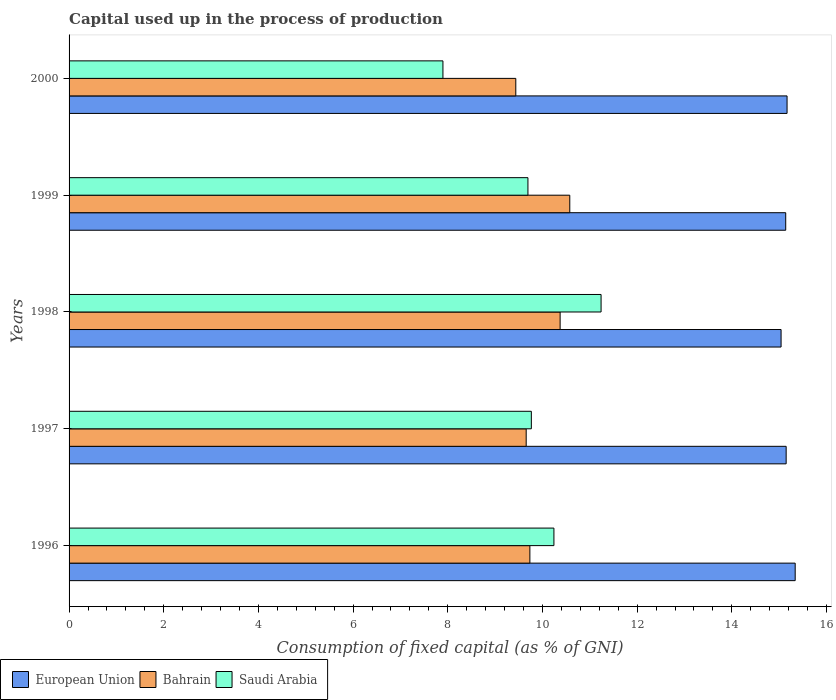How many groups of bars are there?
Offer a terse response. 5. Are the number of bars on each tick of the Y-axis equal?
Your answer should be very brief. Yes. What is the label of the 3rd group of bars from the top?
Offer a terse response. 1998. What is the capital used up in the process of production in Saudi Arabia in 1996?
Your response must be concise. 10.24. Across all years, what is the maximum capital used up in the process of production in Bahrain?
Your answer should be compact. 10.58. Across all years, what is the minimum capital used up in the process of production in European Union?
Your response must be concise. 15.04. In which year was the capital used up in the process of production in European Union maximum?
Provide a succinct answer. 1996. In which year was the capital used up in the process of production in Bahrain minimum?
Give a very brief answer. 2000. What is the total capital used up in the process of production in European Union in the graph?
Make the answer very short. 75.83. What is the difference between the capital used up in the process of production in European Union in 1999 and that in 2000?
Give a very brief answer. -0.03. What is the difference between the capital used up in the process of production in European Union in 2000 and the capital used up in the process of production in Saudi Arabia in 1998?
Your answer should be compact. 3.93. What is the average capital used up in the process of production in Saudi Arabia per year?
Give a very brief answer. 9.77. In the year 1999, what is the difference between the capital used up in the process of production in European Union and capital used up in the process of production in Saudi Arabia?
Offer a very short reply. 5.45. What is the ratio of the capital used up in the process of production in Saudi Arabia in 1997 to that in 2000?
Provide a succinct answer. 1.24. Is the capital used up in the process of production in European Union in 1999 less than that in 2000?
Ensure brevity in your answer.  Yes. What is the difference between the highest and the second highest capital used up in the process of production in Bahrain?
Ensure brevity in your answer.  0.2. What is the difference between the highest and the lowest capital used up in the process of production in Saudi Arabia?
Your response must be concise. 3.34. In how many years, is the capital used up in the process of production in Bahrain greater than the average capital used up in the process of production in Bahrain taken over all years?
Offer a very short reply. 2. Is the sum of the capital used up in the process of production in European Union in 1996 and 1998 greater than the maximum capital used up in the process of production in Saudi Arabia across all years?
Offer a very short reply. Yes. What does the 1st bar from the top in 1998 represents?
Offer a terse response. Saudi Arabia. What does the 3rd bar from the bottom in 2000 represents?
Make the answer very short. Saudi Arabia. Is it the case that in every year, the sum of the capital used up in the process of production in Saudi Arabia and capital used up in the process of production in European Union is greater than the capital used up in the process of production in Bahrain?
Offer a very short reply. Yes. How many bars are there?
Your response must be concise. 15. Are all the bars in the graph horizontal?
Offer a terse response. Yes. How many years are there in the graph?
Offer a very short reply. 5. How are the legend labels stacked?
Your answer should be compact. Horizontal. What is the title of the graph?
Provide a succinct answer. Capital used up in the process of production. What is the label or title of the X-axis?
Keep it short and to the point. Consumption of fixed capital (as % of GNI). What is the Consumption of fixed capital (as % of GNI) in European Union in 1996?
Ensure brevity in your answer.  15.34. What is the Consumption of fixed capital (as % of GNI) of Bahrain in 1996?
Keep it short and to the point. 9.73. What is the Consumption of fixed capital (as % of GNI) in Saudi Arabia in 1996?
Offer a very short reply. 10.24. What is the Consumption of fixed capital (as % of GNI) of European Union in 1997?
Offer a very short reply. 15.15. What is the Consumption of fixed capital (as % of GNI) of Bahrain in 1997?
Make the answer very short. 9.66. What is the Consumption of fixed capital (as % of GNI) of Saudi Arabia in 1997?
Your answer should be very brief. 9.76. What is the Consumption of fixed capital (as % of GNI) in European Union in 1998?
Provide a short and direct response. 15.04. What is the Consumption of fixed capital (as % of GNI) of Bahrain in 1998?
Provide a succinct answer. 10.37. What is the Consumption of fixed capital (as % of GNI) in Saudi Arabia in 1998?
Make the answer very short. 11.24. What is the Consumption of fixed capital (as % of GNI) in European Union in 1999?
Offer a terse response. 15.14. What is the Consumption of fixed capital (as % of GNI) of Bahrain in 1999?
Your answer should be compact. 10.58. What is the Consumption of fixed capital (as % of GNI) in Saudi Arabia in 1999?
Keep it short and to the point. 9.69. What is the Consumption of fixed capital (as % of GNI) in European Union in 2000?
Your answer should be compact. 15.17. What is the Consumption of fixed capital (as % of GNI) in Bahrain in 2000?
Keep it short and to the point. 9.44. What is the Consumption of fixed capital (as % of GNI) of Saudi Arabia in 2000?
Make the answer very short. 7.9. Across all years, what is the maximum Consumption of fixed capital (as % of GNI) of European Union?
Offer a very short reply. 15.34. Across all years, what is the maximum Consumption of fixed capital (as % of GNI) of Bahrain?
Keep it short and to the point. 10.58. Across all years, what is the maximum Consumption of fixed capital (as % of GNI) in Saudi Arabia?
Provide a short and direct response. 11.24. Across all years, what is the minimum Consumption of fixed capital (as % of GNI) of European Union?
Offer a terse response. 15.04. Across all years, what is the minimum Consumption of fixed capital (as % of GNI) of Bahrain?
Your answer should be very brief. 9.44. Across all years, what is the minimum Consumption of fixed capital (as % of GNI) of Saudi Arabia?
Keep it short and to the point. 7.9. What is the total Consumption of fixed capital (as % of GNI) in European Union in the graph?
Offer a terse response. 75.83. What is the total Consumption of fixed capital (as % of GNI) of Bahrain in the graph?
Ensure brevity in your answer.  49.77. What is the total Consumption of fixed capital (as % of GNI) in Saudi Arabia in the graph?
Ensure brevity in your answer.  48.83. What is the difference between the Consumption of fixed capital (as % of GNI) of European Union in 1996 and that in 1997?
Provide a succinct answer. 0.19. What is the difference between the Consumption of fixed capital (as % of GNI) of Bahrain in 1996 and that in 1997?
Make the answer very short. 0.08. What is the difference between the Consumption of fixed capital (as % of GNI) of Saudi Arabia in 1996 and that in 1997?
Ensure brevity in your answer.  0.48. What is the difference between the Consumption of fixed capital (as % of GNI) of European Union in 1996 and that in 1998?
Make the answer very short. 0.3. What is the difference between the Consumption of fixed capital (as % of GNI) of Bahrain in 1996 and that in 1998?
Offer a terse response. -0.64. What is the difference between the Consumption of fixed capital (as % of GNI) of Saudi Arabia in 1996 and that in 1998?
Ensure brevity in your answer.  -1. What is the difference between the Consumption of fixed capital (as % of GNI) in European Union in 1996 and that in 1999?
Offer a very short reply. 0.2. What is the difference between the Consumption of fixed capital (as % of GNI) of Bahrain in 1996 and that in 1999?
Give a very brief answer. -0.84. What is the difference between the Consumption of fixed capital (as % of GNI) in Saudi Arabia in 1996 and that in 1999?
Offer a terse response. 0.55. What is the difference between the Consumption of fixed capital (as % of GNI) of European Union in 1996 and that in 2000?
Your answer should be compact. 0.17. What is the difference between the Consumption of fixed capital (as % of GNI) of Bahrain in 1996 and that in 2000?
Your answer should be compact. 0.3. What is the difference between the Consumption of fixed capital (as % of GNI) in Saudi Arabia in 1996 and that in 2000?
Keep it short and to the point. 2.34. What is the difference between the Consumption of fixed capital (as % of GNI) of European Union in 1997 and that in 1998?
Keep it short and to the point. 0.11. What is the difference between the Consumption of fixed capital (as % of GNI) of Bahrain in 1997 and that in 1998?
Offer a terse response. -0.72. What is the difference between the Consumption of fixed capital (as % of GNI) in Saudi Arabia in 1997 and that in 1998?
Make the answer very short. -1.47. What is the difference between the Consumption of fixed capital (as % of GNI) in European Union in 1997 and that in 1999?
Offer a terse response. 0.01. What is the difference between the Consumption of fixed capital (as % of GNI) of Bahrain in 1997 and that in 1999?
Give a very brief answer. -0.92. What is the difference between the Consumption of fixed capital (as % of GNI) in Saudi Arabia in 1997 and that in 1999?
Your answer should be compact. 0.07. What is the difference between the Consumption of fixed capital (as % of GNI) of European Union in 1997 and that in 2000?
Give a very brief answer. -0.02. What is the difference between the Consumption of fixed capital (as % of GNI) in Bahrain in 1997 and that in 2000?
Keep it short and to the point. 0.22. What is the difference between the Consumption of fixed capital (as % of GNI) of Saudi Arabia in 1997 and that in 2000?
Keep it short and to the point. 1.87. What is the difference between the Consumption of fixed capital (as % of GNI) in European Union in 1998 and that in 1999?
Your answer should be very brief. -0.1. What is the difference between the Consumption of fixed capital (as % of GNI) of Bahrain in 1998 and that in 1999?
Your answer should be compact. -0.2. What is the difference between the Consumption of fixed capital (as % of GNI) in Saudi Arabia in 1998 and that in 1999?
Give a very brief answer. 1.55. What is the difference between the Consumption of fixed capital (as % of GNI) of European Union in 1998 and that in 2000?
Your response must be concise. -0.13. What is the difference between the Consumption of fixed capital (as % of GNI) of Bahrain in 1998 and that in 2000?
Your response must be concise. 0.94. What is the difference between the Consumption of fixed capital (as % of GNI) of Saudi Arabia in 1998 and that in 2000?
Offer a terse response. 3.34. What is the difference between the Consumption of fixed capital (as % of GNI) of European Union in 1999 and that in 2000?
Provide a short and direct response. -0.03. What is the difference between the Consumption of fixed capital (as % of GNI) in Bahrain in 1999 and that in 2000?
Provide a succinct answer. 1.14. What is the difference between the Consumption of fixed capital (as % of GNI) in Saudi Arabia in 1999 and that in 2000?
Give a very brief answer. 1.8. What is the difference between the Consumption of fixed capital (as % of GNI) in European Union in 1996 and the Consumption of fixed capital (as % of GNI) in Bahrain in 1997?
Your answer should be very brief. 5.68. What is the difference between the Consumption of fixed capital (as % of GNI) in European Union in 1996 and the Consumption of fixed capital (as % of GNI) in Saudi Arabia in 1997?
Offer a terse response. 5.57. What is the difference between the Consumption of fixed capital (as % of GNI) of Bahrain in 1996 and the Consumption of fixed capital (as % of GNI) of Saudi Arabia in 1997?
Give a very brief answer. -0.03. What is the difference between the Consumption of fixed capital (as % of GNI) of European Union in 1996 and the Consumption of fixed capital (as % of GNI) of Bahrain in 1998?
Offer a very short reply. 4.97. What is the difference between the Consumption of fixed capital (as % of GNI) in European Union in 1996 and the Consumption of fixed capital (as % of GNI) in Saudi Arabia in 1998?
Your response must be concise. 4.1. What is the difference between the Consumption of fixed capital (as % of GNI) in Bahrain in 1996 and the Consumption of fixed capital (as % of GNI) in Saudi Arabia in 1998?
Give a very brief answer. -1.5. What is the difference between the Consumption of fixed capital (as % of GNI) in European Union in 1996 and the Consumption of fixed capital (as % of GNI) in Bahrain in 1999?
Make the answer very short. 4.76. What is the difference between the Consumption of fixed capital (as % of GNI) in European Union in 1996 and the Consumption of fixed capital (as % of GNI) in Saudi Arabia in 1999?
Give a very brief answer. 5.65. What is the difference between the Consumption of fixed capital (as % of GNI) of Bahrain in 1996 and the Consumption of fixed capital (as % of GNI) of Saudi Arabia in 1999?
Your response must be concise. 0.04. What is the difference between the Consumption of fixed capital (as % of GNI) of European Union in 1996 and the Consumption of fixed capital (as % of GNI) of Bahrain in 2000?
Offer a very short reply. 5.9. What is the difference between the Consumption of fixed capital (as % of GNI) of European Union in 1996 and the Consumption of fixed capital (as % of GNI) of Saudi Arabia in 2000?
Your answer should be compact. 7.44. What is the difference between the Consumption of fixed capital (as % of GNI) in Bahrain in 1996 and the Consumption of fixed capital (as % of GNI) in Saudi Arabia in 2000?
Your response must be concise. 1.84. What is the difference between the Consumption of fixed capital (as % of GNI) of European Union in 1997 and the Consumption of fixed capital (as % of GNI) of Bahrain in 1998?
Your answer should be compact. 4.77. What is the difference between the Consumption of fixed capital (as % of GNI) in European Union in 1997 and the Consumption of fixed capital (as % of GNI) in Saudi Arabia in 1998?
Ensure brevity in your answer.  3.91. What is the difference between the Consumption of fixed capital (as % of GNI) of Bahrain in 1997 and the Consumption of fixed capital (as % of GNI) of Saudi Arabia in 1998?
Offer a very short reply. -1.58. What is the difference between the Consumption of fixed capital (as % of GNI) of European Union in 1997 and the Consumption of fixed capital (as % of GNI) of Bahrain in 1999?
Your response must be concise. 4.57. What is the difference between the Consumption of fixed capital (as % of GNI) of European Union in 1997 and the Consumption of fixed capital (as % of GNI) of Saudi Arabia in 1999?
Your answer should be very brief. 5.45. What is the difference between the Consumption of fixed capital (as % of GNI) in Bahrain in 1997 and the Consumption of fixed capital (as % of GNI) in Saudi Arabia in 1999?
Your answer should be very brief. -0.04. What is the difference between the Consumption of fixed capital (as % of GNI) of European Union in 1997 and the Consumption of fixed capital (as % of GNI) of Bahrain in 2000?
Your response must be concise. 5.71. What is the difference between the Consumption of fixed capital (as % of GNI) of European Union in 1997 and the Consumption of fixed capital (as % of GNI) of Saudi Arabia in 2000?
Keep it short and to the point. 7.25. What is the difference between the Consumption of fixed capital (as % of GNI) in Bahrain in 1997 and the Consumption of fixed capital (as % of GNI) in Saudi Arabia in 2000?
Your answer should be very brief. 1.76. What is the difference between the Consumption of fixed capital (as % of GNI) of European Union in 1998 and the Consumption of fixed capital (as % of GNI) of Bahrain in 1999?
Provide a succinct answer. 4.46. What is the difference between the Consumption of fixed capital (as % of GNI) in European Union in 1998 and the Consumption of fixed capital (as % of GNI) in Saudi Arabia in 1999?
Keep it short and to the point. 5.35. What is the difference between the Consumption of fixed capital (as % of GNI) in Bahrain in 1998 and the Consumption of fixed capital (as % of GNI) in Saudi Arabia in 1999?
Provide a short and direct response. 0.68. What is the difference between the Consumption of fixed capital (as % of GNI) in European Union in 1998 and the Consumption of fixed capital (as % of GNI) in Bahrain in 2000?
Keep it short and to the point. 5.6. What is the difference between the Consumption of fixed capital (as % of GNI) of European Union in 1998 and the Consumption of fixed capital (as % of GNI) of Saudi Arabia in 2000?
Give a very brief answer. 7.14. What is the difference between the Consumption of fixed capital (as % of GNI) of Bahrain in 1998 and the Consumption of fixed capital (as % of GNI) of Saudi Arabia in 2000?
Provide a short and direct response. 2.48. What is the difference between the Consumption of fixed capital (as % of GNI) of European Union in 1999 and the Consumption of fixed capital (as % of GNI) of Bahrain in 2000?
Your response must be concise. 5.7. What is the difference between the Consumption of fixed capital (as % of GNI) in European Union in 1999 and the Consumption of fixed capital (as % of GNI) in Saudi Arabia in 2000?
Offer a very short reply. 7.24. What is the difference between the Consumption of fixed capital (as % of GNI) in Bahrain in 1999 and the Consumption of fixed capital (as % of GNI) in Saudi Arabia in 2000?
Your answer should be very brief. 2.68. What is the average Consumption of fixed capital (as % of GNI) of European Union per year?
Keep it short and to the point. 15.17. What is the average Consumption of fixed capital (as % of GNI) in Bahrain per year?
Your answer should be compact. 9.96. What is the average Consumption of fixed capital (as % of GNI) in Saudi Arabia per year?
Offer a very short reply. 9.77. In the year 1996, what is the difference between the Consumption of fixed capital (as % of GNI) of European Union and Consumption of fixed capital (as % of GNI) of Bahrain?
Your answer should be compact. 5.6. In the year 1996, what is the difference between the Consumption of fixed capital (as % of GNI) of European Union and Consumption of fixed capital (as % of GNI) of Saudi Arabia?
Keep it short and to the point. 5.1. In the year 1996, what is the difference between the Consumption of fixed capital (as % of GNI) in Bahrain and Consumption of fixed capital (as % of GNI) in Saudi Arabia?
Your response must be concise. -0.51. In the year 1997, what is the difference between the Consumption of fixed capital (as % of GNI) of European Union and Consumption of fixed capital (as % of GNI) of Bahrain?
Give a very brief answer. 5.49. In the year 1997, what is the difference between the Consumption of fixed capital (as % of GNI) in European Union and Consumption of fixed capital (as % of GNI) in Saudi Arabia?
Provide a succinct answer. 5.38. In the year 1997, what is the difference between the Consumption of fixed capital (as % of GNI) in Bahrain and Consumption of fixed capital (as % of GNI) in Saudi Arabia?
Offer a terse response. -0.11. In the year 1998, what is the difference between the Consumption of fixed capital (as % of GNI) in European Union and Consumption of fixed capital (as % of GNI) in Bahrain?
Make the answer very short. 4.67. In the year 1998, what is the difference between the Consumption of fixed capital (as % of GNI) in European Union and Consumption of fixed capital (as % of GNI) in Saudi Arabia?
Give a very brief answer. 3.8. In the year 1998, what is the difference between the Consumption of fixed capital (as % of GNI) of Bahrain and Consumption of fixed capital (as % of GNI) of Saudi Arabia?
Your answer should be compact. -0.87. In the year 1999, what is the difference between the Consumption of fixed capital (as % of GNI) in European Union and Consumption of fixed capital (as % of GNI) in Bahrain?
Keep it short and to the point. 4.56. In the year 1999, what is the difference between the Consumption of fixed capital (as % of GNI) of European Union and Consumption of fixed capital (as % of GNI) of Saudi Arabia?
Keep it short and to the point. 5.45. In the year 1999, what is the difference between the Consumption of fixed capital (as % of GNI) in Bahrain and Consumption of fixed capital (as % of GNI) in Saudi Arabia?
Give a very brief answer. 0.88. In the year 2000, what is the difference between the Consumption of fixed capital (as % of GNI) in European Union and Consumption of fixed capital (as % of GNI) in Bahrain?
Offer a very short reply. 5.73. In the year 2000, what is the difference between the Consumption of fixed capital (as % of GNI) of European Union and Consumption of fixed capital (as % of GNI) of Saudi Arabia?
Your response must be concise. 7.27. In the year 2000, what is the difference between the Consumption of fixed capital (as % of GNI) of Bahrain and Consumption of fixed capital (as % of GNI) of Saudi Arabia?
Make the answer very short. 1.54. What is the ratio of the Consumption of fixed capital (as % of GNI) in European Union in 1996 to that in 1997?
Give a very brief answer. 1.01. What is the ratio of the Consumption of fixed capital (as % of GNI) in Bahrain in 1996 to that in 1997?
Ensure brevity in your answer.  1.01. What is the ratio of the Consumption of fixed capital (as % of GNI) of Saudi Arabia in 1996 to that in 1997?
Keep it short and to the point. 1.05. What is the ratio of the Consumption of fixed capital (as % of GNI) of European Union in 1996 to that in 1998?
Give a very brief answer. 1.02. What is the ratio of the Consumption of fixed capital (as % of GNI) in Bahrain in 1996 to that in 1998?
Keep it short and to the point. 0.94. What is the ratio of the Consumption of fixed capital (as % of GNI) in Saudi Arabia in 1996 to that in 1998?
Offer a very short reply. 0.91. What is the ratio of the Consumption of fixed capital (as % of GNI) of European Union in 1996 to that in 1999?
Keep it short and to the point. 1.01. What is the ratio of the Consumption of fixed capital (as % of GNI) of Bahrain in 1996 to that in 1999?
Give a very brief answer. 0.92. What is the ratio of the Consumption of fixed capital (as % of GNI) in Saudi Arabia in 1996 to that in 1999?
Your answer should be compact. 1.06. What is the ratio of the Consumption of fixed capital (as % of GNI) in European Union in 1996 to that in 2000?
Offer a terse response. 1.01. What is the ratio of the Consumption of fixed capital (as % of GNI) of Bahrain in 1996 to that in 2000?
Ensure brevity in your answer.  1.03. What is the ratio of the Consumption of fixed capital (as % of GNI) of Saudi Arabia in 1996 to that in 2000?
Your response must be concise. 1.3. What is the ratio of the Consumption of fixed capital (as % of GNI) of European Union in 1997 to that in 1998?
Provide a short and direct response. 1.01. What is the ratio of the Consumption of fixed capital (as % of GNI) in Bahrain in 1997 to that in 1998?
Your answer should be compact. 0.93. What is the ratio of the Consumption of fixed capital (as % of GNI) in Saudi Arabia in 1997 to that in 1998?
Your response must be concise. 0.87. What is the ratio of the Consumption of fixed capital (as % of GNI) in Bahrain in 1997 to that in 1999?
Give a very brief answer. 0.91. What is the ratio of the Consumption of fixed capital (as % of GNI) in Saudi Arabia in 1997 to that in 1999?
Provide a succinct answer. 1.01. What is the ratio of the Consumption of fixed capital (as % of GNI) in European Union in 1997 to that in 2000?
Ensure brevity in your answer.  1. What is the ratio of the Consumption of fixed capital (as % of GNI) in Bahrain in 1997 to that in 2000?
Provide a succinct answer. 1.02. What is the ratio of the Consumption of fixed capital (as % of GNI) of Saudi Arabia in 1997 to that in 2000?
Offer a very short reply. 1.24. What is the ratio of the Consumption of fixed capital (as % of GNI) of Bahrain in 1998 to that in 1999?
Provide a succinct answer. 0.98. What is the ratio of the Consumption of fixed capital (as % of GNI) in Saudi Arabia in 1998 to that in 1999?
Keep it short and to the point. 1.16. What is the ratio of the Consumption of fixed capital (as % of GNI) of European Union in 1998 to that in 2000?
Give a very brief answer. 0.99. What is the ratio of the Consumption of fixed capital (as % of GNI) in Bahrain in 1998 to that in 2000?
Make the answer very short. 1.1. What is the ratio of the Consumption of fixed capital (as % of GNI) of Saudi Arabia in 1998 to that in 2000?
Your response must be concise. 1.42. What is the ratio of the Consumption of fixed capital (as % of GNI) in Bahrain in 1999 to that in 2000?
Ensure brevity in your answer.  1.12. What is the ratio of the Consumption of fixed capital (as % of GNI) in Saudi Arabia in 1999 to that in 2000?
Provide a succinct answer. 1.23. What is the difference between the highest and the second highest Consumption of fixed capital (as % of GNI) of European Union?
Provide a short and direct response. 0.17. What is the difference between the highest and the second highest Consumption of fixed capital (as % of GNI) of Bahrain?
Provide a succinct answer. 0.2. What is the difference between the highest and the second highest Consumption of fixed capital (as % of GNI) in Saudi Arabia?
Make the answer very short. 1. What is the difference between the highest and the lowest Consumption of fixed capital (as % of GNI) in European Union?
Give a very brief answer. 0.3. What is the difference between the highest and the lowest Consumption of fixed capital (as % of GNI) of Bahrain?
Offer a terse response. 1.14. What is the difference between the highest and the lowest Consumption of fixed capital (as % of GNI) in Saudi Arabia?
Your answer should be very brief. 3.34. 